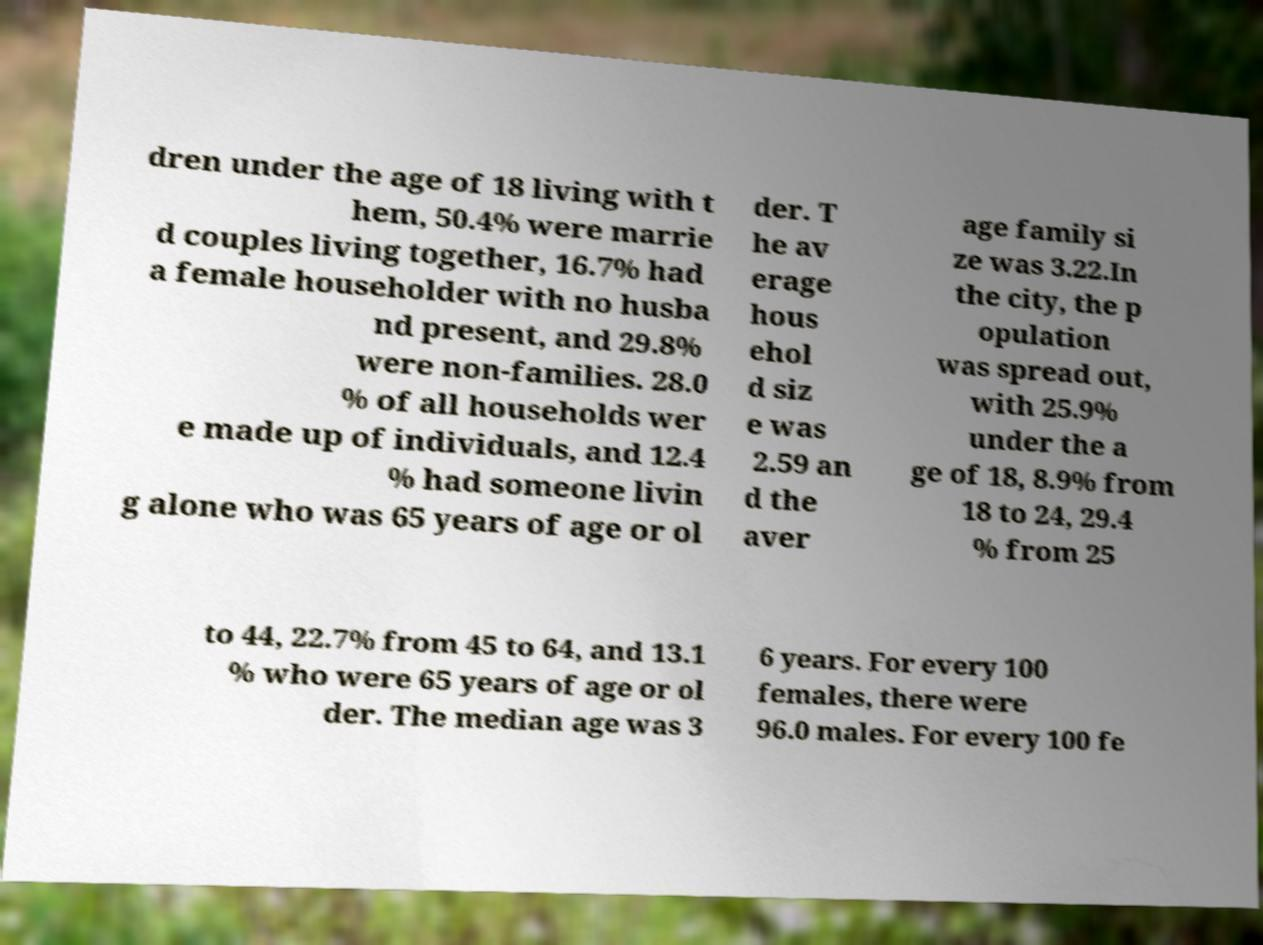Please read and relay the text visible in this image. What does it say? dren under the age of 18 living with t hem, 50.4% were marrie d couples living together, 16.7% had a female householder with no husba nd present, and 29.8% were non-families. 28.0 % of all households wer e made up of individuals, and 12.4 % had someone livin g alone who was 65 years of age or ol der. T he av erage hous ehol d siz e was 2.59 an d the aver age family si ze was 3.22.In the city, the p opulation was spread out, with 25.9% under the a ge of 18, 8.9% from 18 to 24, 29.4 % from 25 to 44, 22.7% from 45 to 64, and 13.1 % who were 65 years of age or ol der. The median age was 3 6 years. For every 100 females, there were 96.0 males. For every 100 fe 